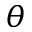Convert formula to latex. <formula><loc_0><loc_0><loc_500><loc_500>\theta</formula> 